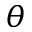Convert formula to latex. <formula><loc_0><loc_0><loc_500><loc_500>\theta</formula> 